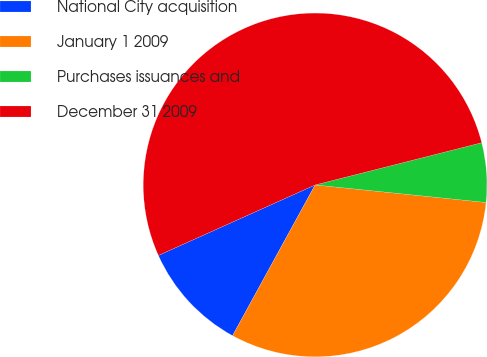Convert chart. <chart><loc_0><loc_0><loc_500><loc_500><pie_chart><fcel>National City acquisition<fcel>January 1 2009<fcel>Purchases issuances and<fcel>December 31 2009<nl><fcel>10.3%<fcel>31.35%<fcel>5.58%<fcel>52.78%<nl></chart> 